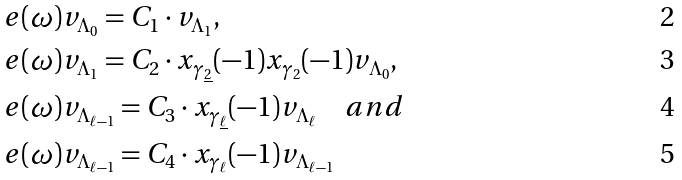Convert formula to latex. <formula><loc_0><loc_0><loc_500><loc_500>e ( \omega ) & v _ { \Lambda _ { 0 } } = C _ { 1 } \cdot v _ { \Lambda _ { 1 } } , \\ e ( \omega ) & v _ { \Lambda _ { 1 } } = C _ { 2 } \cdot x _ { \gamma _ { \underline { 2 } } } ( - 1 ) x _ { \gamma _ { 2 } } ( - 1 ) v _ { \Lambda _ { 0 } } , \\ e ( \omega ) & v _ { \Lambda _ { \ell - 1 } } = C _ { 3 } \cdot x _ { \gamma _ { \underline { \ell } } } ( - 1 ) v _ { \Lambda _ { \ell } } \quad a n d \\ e ( \omega ) & v _ { \Lambda _ { \ell - 1 } } = C _ { 4 } \cdot x _ { \gamma _ { \ell } } ( - 1 ) v _ { \Lambda _ { \ell - 1 } }</formula> 